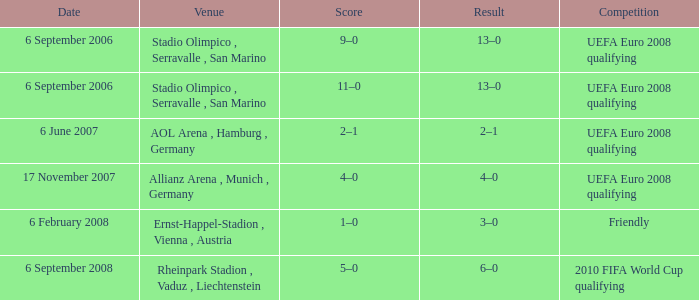Could you parse the entire table? {'header': ['Date', 'Venue', 'Score', 'Result', 'Competition'], 'rows': [['6 September 2006', 'Stadio Olimpico , Serravalle , San Marino', '9–0', '13–0', 'UEFA Euro 2008 qualifying'], ['6 September 2006', 'Stadio Olimpico , Serravalle , San Marino', '11–0', '13–0', 'UEFA Euro 2008 qualifying'], ['6 June 2007', 'AOL Arena , Hamburg , Germany', '2–1', '2–1', 'UEFA Euro 2008 qualifying'], ['17 November 2007', 'Allianz Arena , Munich , Germany', '4–0', '4–0', 'UEFA Euro 2008 qualifying'], ['6 February 2008', 'Ernst-Happel-Stadion , Vienna , Austria', '1–0', '3–0', 'Friendly'], ['6 September 2008', 'Rheinpark Stadion , Vaduz , Liechtenstein', '5–0', '6–0', '2010 FIFA World Cup qualifying']]} On what Date did the friendly Competition take place? 6 February 2008. 